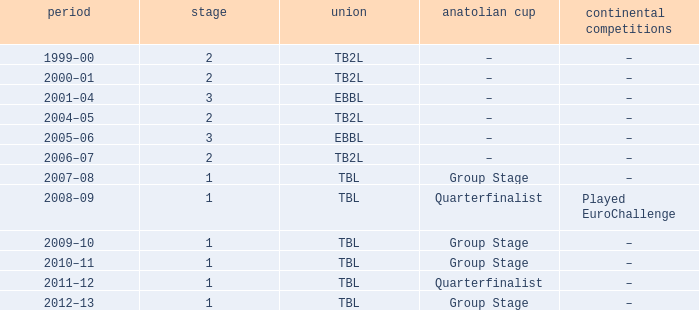Tier of 2, and a Season of 2000–01 is what European competitions? –. 